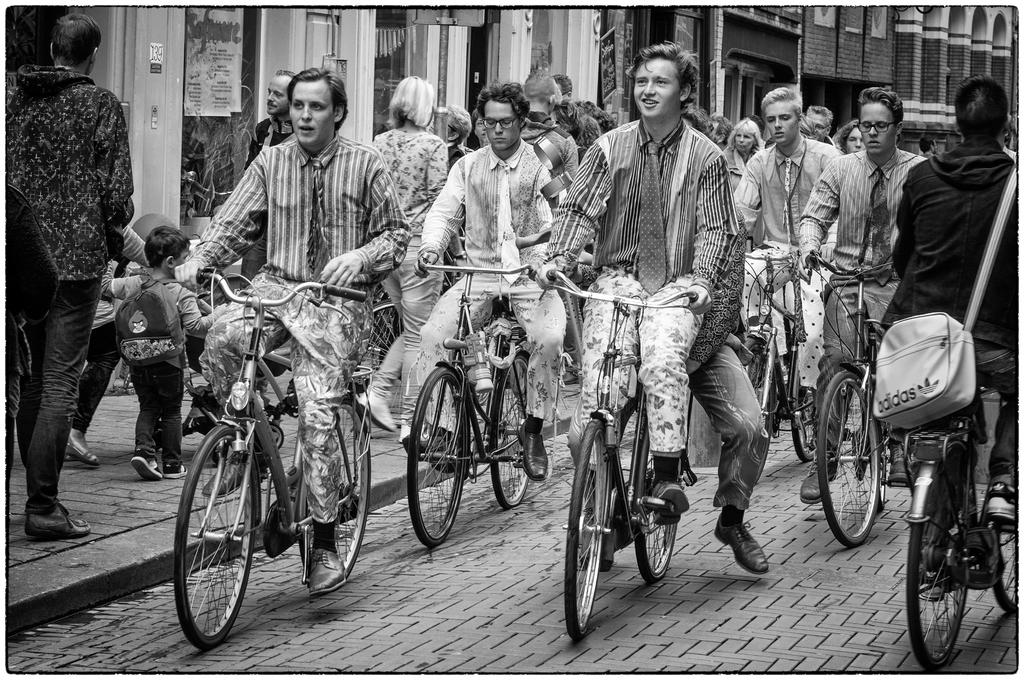What are the people in the image doing? There is a group of people riding a bicycle in the image. Where are the people riding the bicycle? The people are riding the bicycle on a road. What else can be seen in the image besides the bicycle? There are people walking in the image. Where are the people walking? The people walking are on a walkway. What type of yak can be seen grazing on the side of the road in the image? There is no yak present in the image; it features a group of people riding a bicycle and people walking on a walkway. 